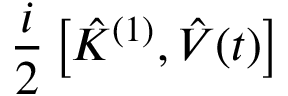<formula> <loc_0><loc_0><loc_500><loc_500>\frac { i } { 2 } \left [ \hat { K } ^ { ( 1 ) } , \hat { V } ( t ) \right ]</formula> 